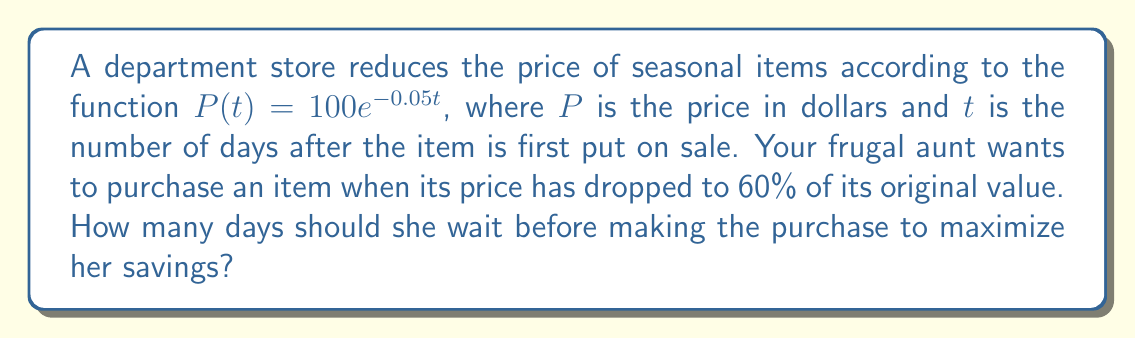Help me with this question. To solve this problem, we need to follow these steps:

1) The original price of the item is $P(0) = 100e^{-0.05(0)} = 100$ dollars.

2) We want to find $t$ when the price is 60% of the original, i.e., $0.6 \times 100 = 60$ dollars.

3) Set up the equation:

   $$60 = 100e^{-0.05t}$$

4) Divide both sides by 100:

   $$0.6 = e^{-0.05t}$$

5) Take the natural logarithm of both sides:

   $$\ln(0.6) = -0.05t$$

6) Solve for $t$:

   $$t = -\frac{\ln(0.6)}{0.05}$$

7) Calculate the value:

   $$t = -\frac{\ln(0.6)}{0.05} \approx 10.2163$$

8) Since we can't wait a fractional number of days, we round up to the next whole number of days.

Therefore, your frugal aunt should wait 11 days before purchasing the item to maximize her savings while ensuring the price has dropped to at least 60% of the original value.
Answer: 11 days 